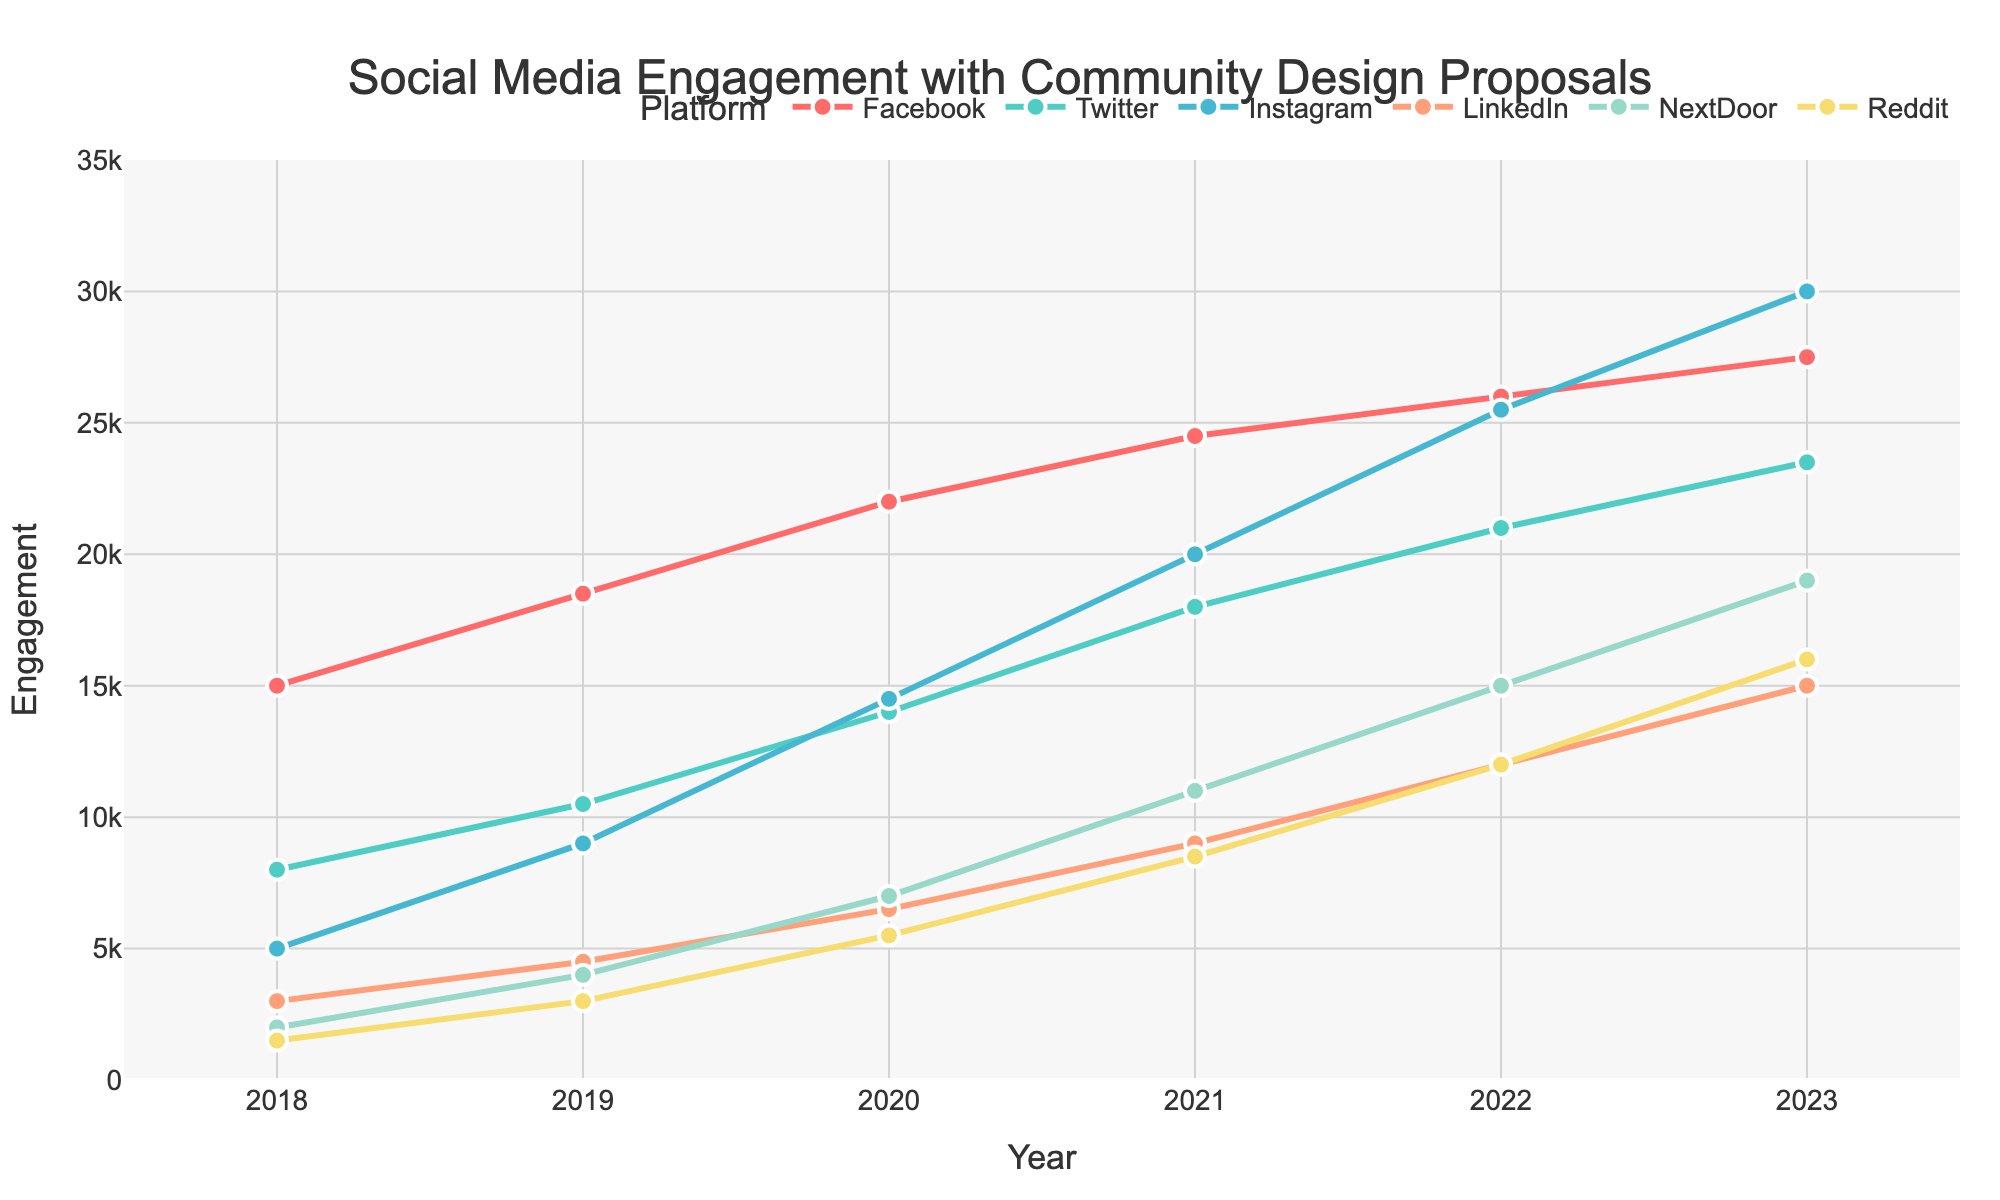What platform had the highest engagement in 2023? By observing the highest point on the graph for the year 2023, we identify that Instagram has the highest engagement.
Answer: Instagram How much did Facebook's engagement grow from 2018 to 2023? First, find Facebook's engagement in 2018 (15,000) and in 2023 (27,500). Then, calculate the difference: 27,500 - 15,000 = 12,500.
Answer: 12,500 Which platforms showed a consistent increase in engagement year over year? By examining the trend lines, it is noticeable that all platforms (Facebook, Twitter, Instagram, LinkedIn, NextDoor, and Reddit) demonstrate a steady increase in engagement each year from 2018 to 2023.
Answer: Facebook, Twitter, Instagram, LinkedIn, NextDoor, Reddit In 2021, which platform had higher engagement: LinkedIn or Reddit? Locate the points for LinkedIn and Reddit on the graph for the year 2021 and compare their heights. LinkedIn had 9,000 while Reddit had 8,500.
Answer: LinkedIn What is the average engagement on Instagram across all the years presented? Sum the engagement values for Instagram from 2018 to 2023 (5,000 + 9,000 + 14,500 + 20,000 + 25,500 + 30,000), then divide by the number of years (6). The calculation is (5,000 + 9,000 + 14,500 + 20,000 + 25,500 + 30,000)/6 = 17,333.33.
Answer: 17,333.33 Which platform had the smallest increase in engagement between 2022 and 2023? Calculate the increase for each platform (difference between 2022 and 2023 values) and identify the smallest increment: Facebook (27,500 - 26,000 = 1,500), Twitter (23,500 - 21,000 = 2,500), Instagram (30,000 - 25,500 = 4,500), LinkedIn (15,000 - 12,000 = 3,000), NextDoor (19,000 - 15,000 = 4,000), Reddit (16,000 - 12,000 = 4,000). The smallest is Facebook with 1,500.
Answer: Facebook What is the total engagement for Reddit across all years? Add the engagement values for Reddit from 2018 to 2023: 1,500 + 3,000 + 5,500 + 8,500 + 12,000 + 16,000 = 46,500.
Answer: 46,500 How does Twitter's engagement in 2020 compare to Facebook's engagement in the same year? Locate Twitter and Facebook engagement values for 2020 on the graph: Twitter is 14,000 and Facebook is 22,000. Thus, Facebook's engagement is higher than Twitter's by 8,000.
Answer: Facebook's is higher by 8,000 Between 2018 and 2023, which year saw the highest average engagement across all platforms? Calculate the average engagement for each year by summing the engagement for all platforms in that year and dividing by the number of platforms (6). The values are: 
2018: (15,000 + 8,000 + 5,000 + 3,000 + 2,000 + 1,500)/6 = 5,750 
2019: (18,500 + 10,500 + 9,000 + 4,500 + 4,000 + 3,000)/6 = 8,583.33
2020: (22,000 + 14,000 + 14,500 + 6,500 + 7,000 + 5,500)/6 = 11,916.67
2021: (24,500 + 18,000 + 20,000 + 9,000 + 11,000 + 8,500)/6 = 15,833.33
2022: (26,000 + 21,000 + 25,500 + 12,000 + 15,000 + 12,000)/6 = 18,250
2023: (27,500 + 23,500 + 30,000 + 15,000 + 19,000 + 16,000)/6 = 21,833.33
The highest average engagement year is 2023 with an average of 21,833.33.
Answer: 2023 